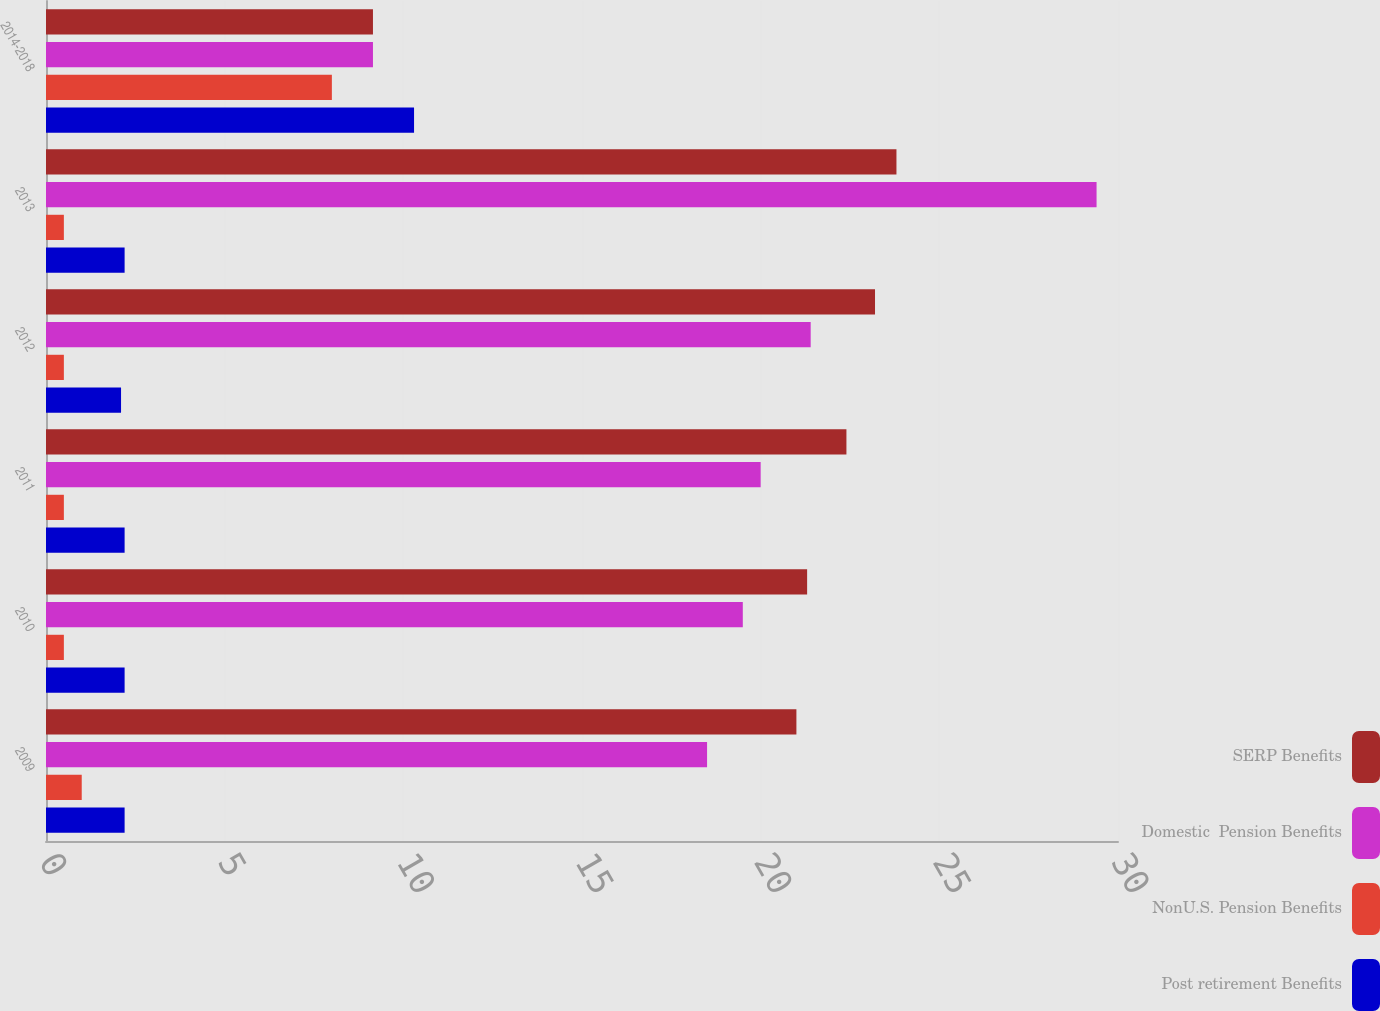Convert chart. <chart><loc_0><loc_0><loc_500><loc_500><stacked_bar_chart><ecel><fcel>2009<fcel>2010<fcel>2011<fcel>2012<fcel>2013<fcel>2014-2018<nl><fcel>SERP Benefits<fcel>21<fcel>21.3<fcel>22.4<fcel>23.2<fcel>23.8<fcel>9.15<nl><fcel>Domestic  Pension Benefits<fcel>18.5<fcel>19.5<fcel>20<fcel>21.4<fcel>29.4<fcel>9.15<nl><fcel>NonU.S. Pension Benefits<fcel>1<fcel>0.5<fcel>0.5<fcel>0.5<fcel>0.5<fcel>8<nl><fcel>Post retirement Benefits<fcel>2.2<fcel>2.2<fcel>2.2<fcel>2.1<fcel>2.2<fcel>10.3<nl></chart> 